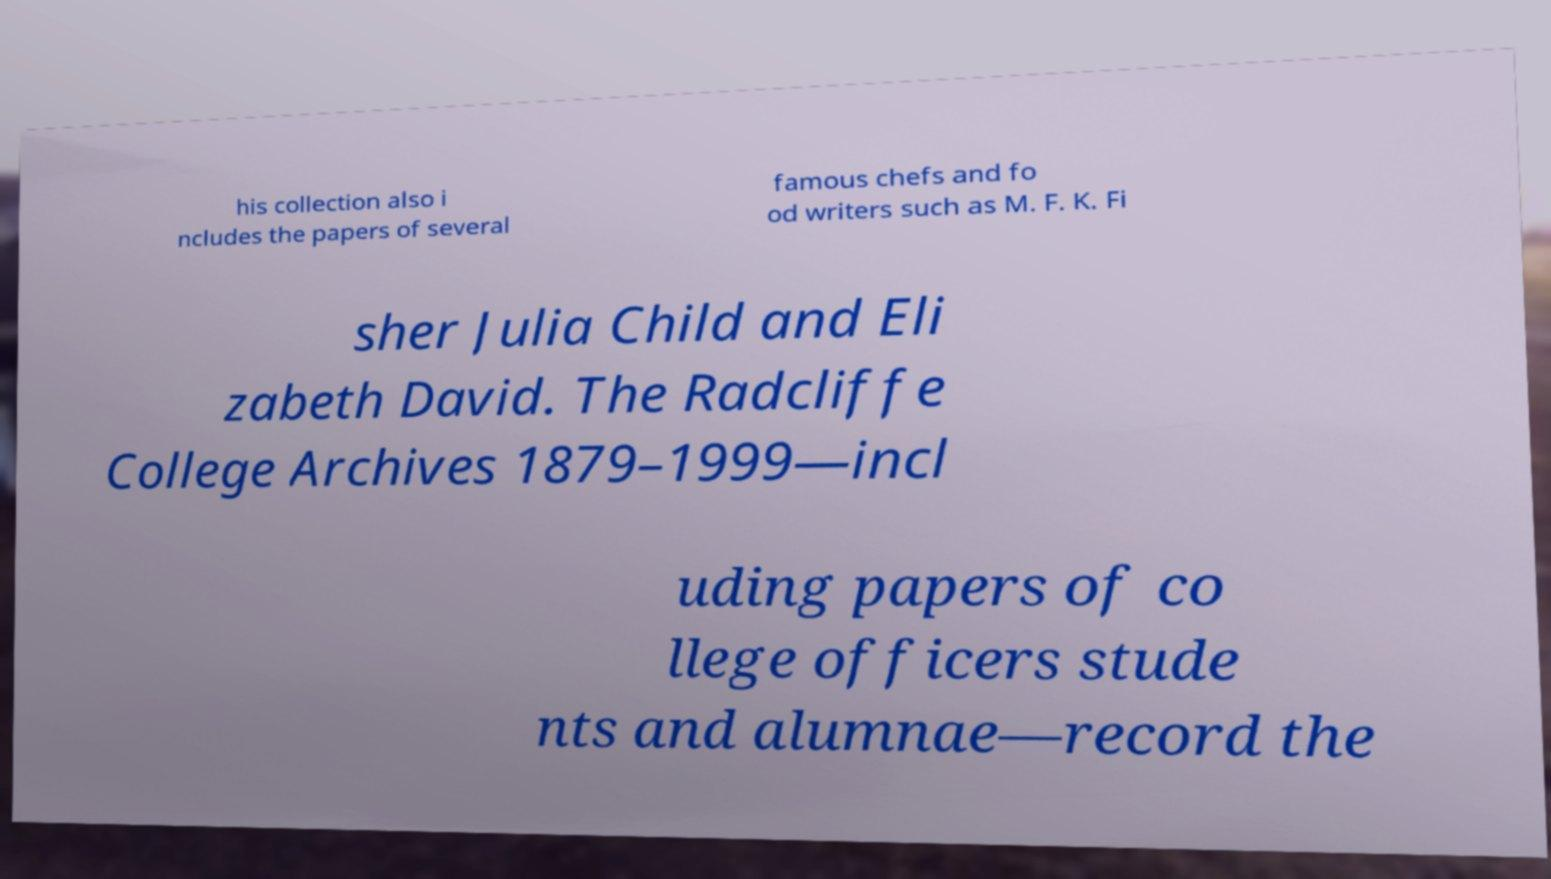Can you read and provide the text displayed in the image?This photo seems to have some interesting text. Can you extract and type it out for me? his collection also i ncludes the papers of several famous chefs and fo od writers such as M. F. K. Fi sher Julia Child and Eli zabeth David. The Radcliffe College Archives 1879–1999—incl uding papers of co llege officers stude nts and alumnae—record the 